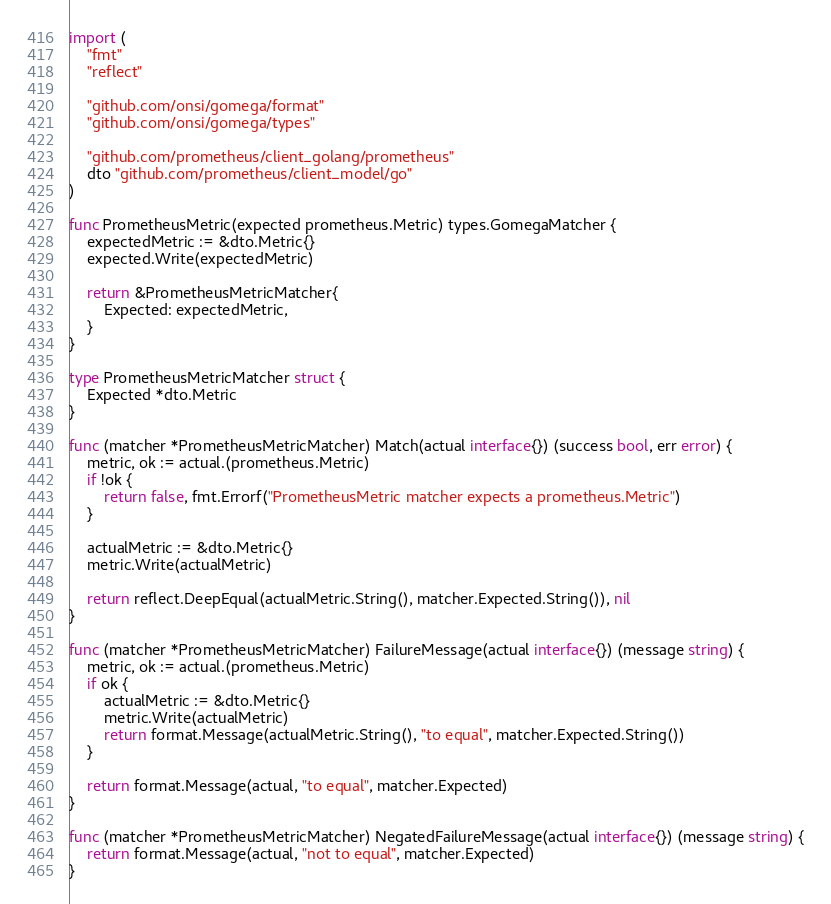<code> <loc_0><loc_0><loc_500><loc_500><_Go_>import (
	"fmt"
	"reflect"

	"github.com/onsi/gomega/format"
	"github.com/onsi/gomega/types"

	"github.com/prometheus/client_golang/prometheus"
	dto "github.com/prometheus/client_model/go"
)

func PrometheusMetric(expected prometheus.Metric) types.GomegaMatcher {
	expectedMetric := &dto.Metric{}
	expected.Write(expectedMetric)

	return &PrometheusMetricMatcher{
		Expected: expectedMetric,
	}
}

type PrometheusMetricMatcher struct {
	Expected *dto.Metric
}

func (matcher *PrometheusMetricMatcher) Match(actual interface{}) (success bool, err error) {
	metric, ok := actual.(prometheus.Metric)
	if !ok {
		return false, fmt.Errorf("PrometheusMetric matcher expects a prometheus.Metric")
	}

	actualMetric := &dto.Metric{}
	metric.Write(actualMetric)

	return reflect.DeepEqual(actualMetric.String(), matcher.Expected.String()), nil
}

func (matcher *PrometheusMetricMatcher) FailureMessage(actual interface{}) (message string) {
	metric, ok := actual.(prometheus.Metric)
	if ok {
		actualMetric := &dto.Metric{}
		metric.Write(actualMetric)
		return format.Message(actualMetric.String(), "to equal", matcher.Expected.String())
	}

	return format.Message(actual, "to equal", matcher.Expected)
}

func (matcher *PrometheusMetricMatcher) NegatedFailureMessage(actual interface{}) (message string) {
	return format.Message(actual, "not to equal", matcher.Expected)
}
</code> 